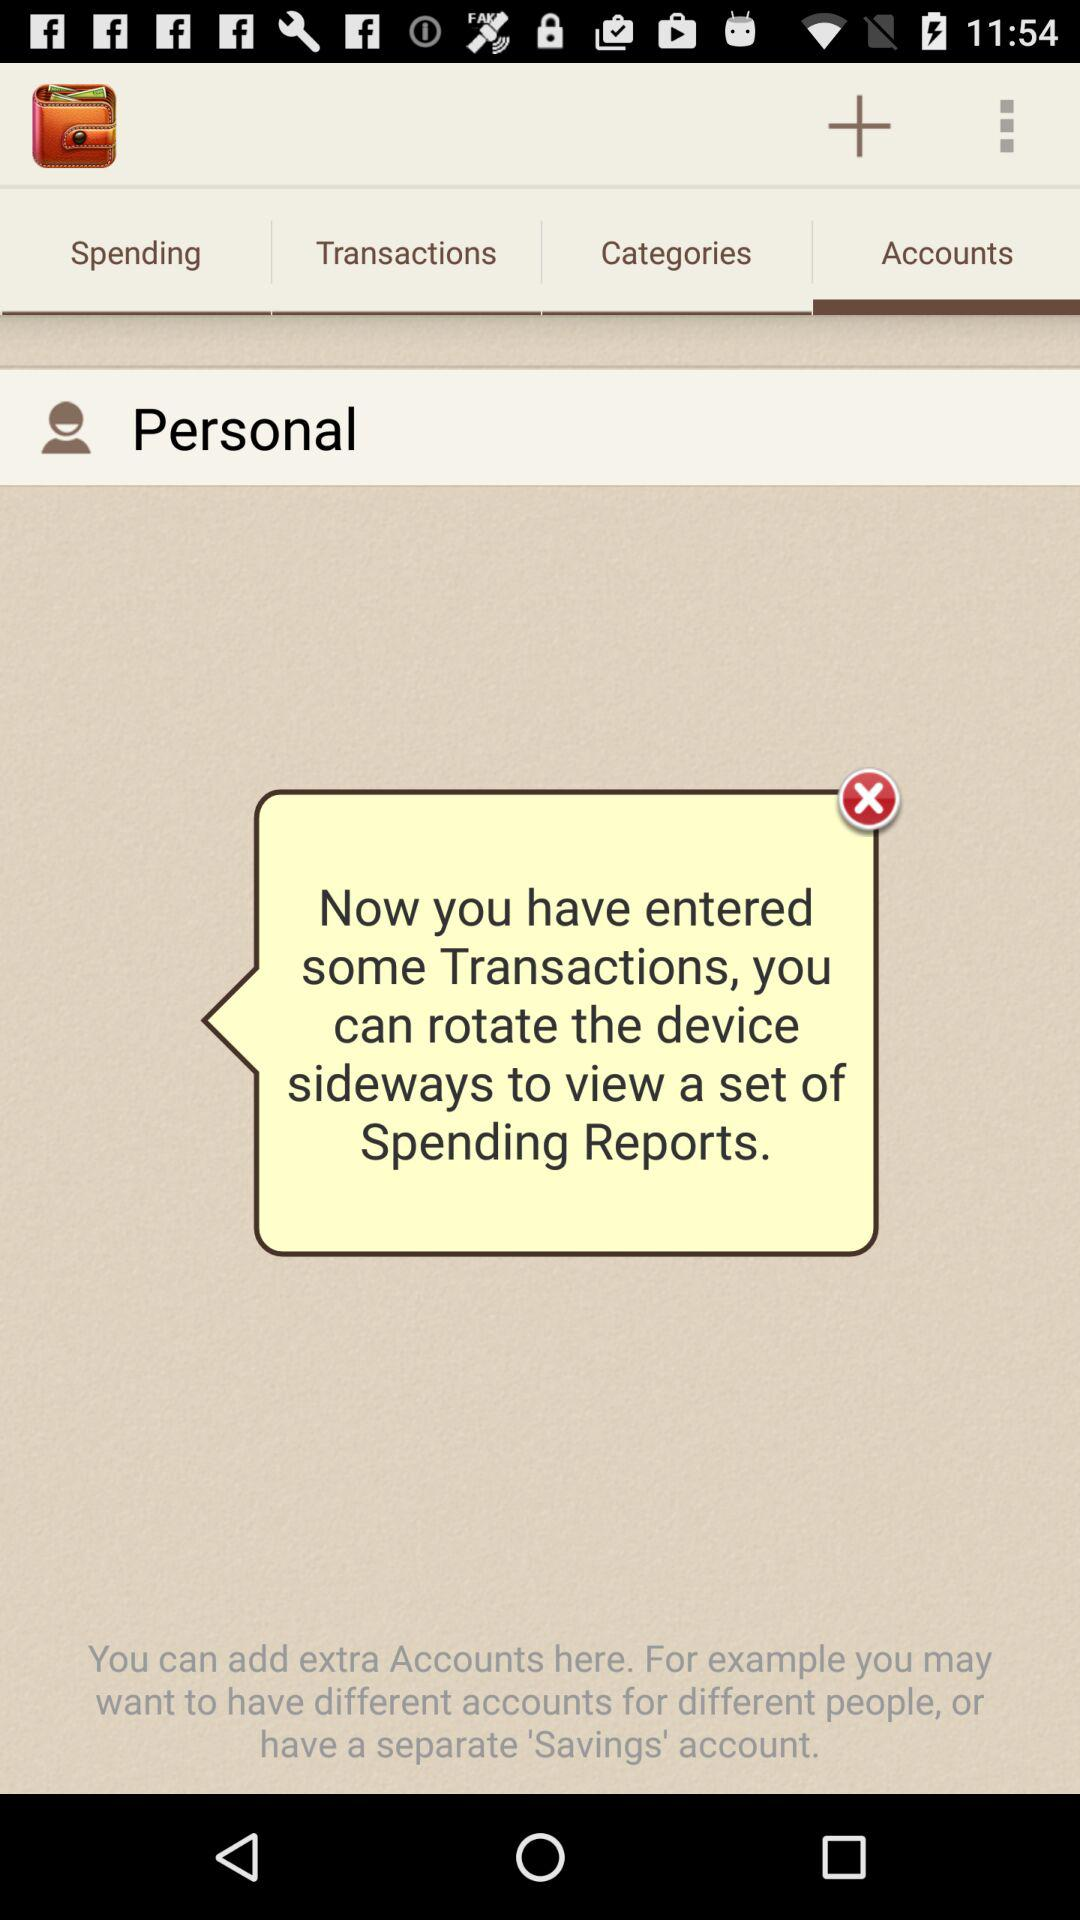How many accounts are available on this screen?
Answer the question using a single word or phrase. 1 